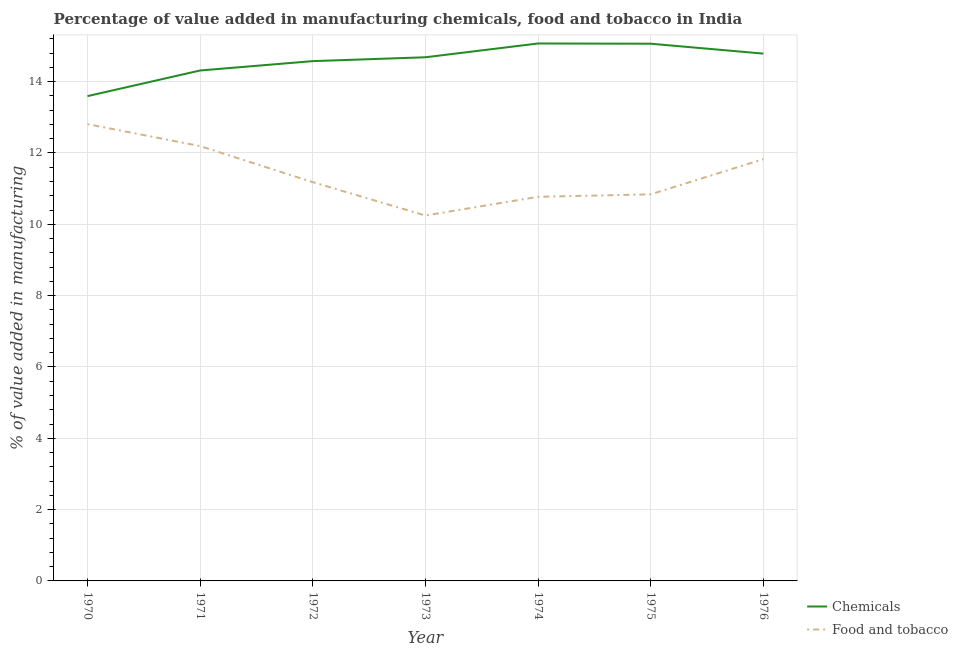Does the line corresponding to value added by  manufacturing chemicals intersect with the line corresponding to value added by manufacturing food and tobacco?
Ensure brevity in your answer.  No. Is the number of lines equal to the number of legend labels?
Provide a short and direct response. Yes. What is the value added by manufacturing food and tobacco in 1970?
Your response must be concise. 12.81. Across all years, what is the maximum value added by  manufacturing chemicals?
Give a very brief answer. 15.07. Across all years, what is the minimum value added by  manufacturing chemicals?
Make the answer very short. 13.59. In which year was the value added by manufacturing food and tobacco maximum?
Provide a short and direct response. 1970. What is the total value added by manufacturing food and tobacco in the graph?
Provide a short and direct response. 79.87. What is the difference between the value added by manufacturing food and tobacco in 1971 and that in 1974?
Give a very brief answer. 1.42. What is the difference between the value added by manufacturing food and tobacco in 1970 and the value added by  manufacturing chemicals in 1971?
Your response must be concise. -1.5. What is the average value added by manufacturing food and tobacco per year?
Give a very brief answer. 11.41. In the year 1976, what is the difference between the value added by manufacturing food and tobacco and value added by  manufacturing chemicals?
Offer a terse response. -2.96. In how many years, is the value added by manufacturing food and tobacco greater than 12.4 %?
Your response must be concise. 1. What is the ratio of the value added by  manufacturing chemicals in 1970 to that in 1974?
Offer a very short reply. 0.9. Is the value added by manufacturing food and tobacco in 1971 less than that in 1973?
Your answer should be compact. No. Is the difference between the value added by  manufacturing chemicals in 1971 and 1972 greater than the difference between the value added by manufacturing food and tobacco in 1971 and 1972?
Give a very brief answer. No. What is the difference between the highest and the second highest value added by  manufacturing chemicals?
Provide a succinct answer. 0.01. What is the difference between the highest and the lowest value added by  manufacturing chemicals?
Provide a short and direct response. 1.48. In how many years, is the value added by manufacturing food and tobacco greater than the average value added by manufacturing food and tobacco taken over all years?
Make the answer very short. 3. Is the sum of the value added by  manufacturing chemicals in 1971 and 1973 greater than the maximum value added by manufacturing food and tobacco across all years?
Make the answer very short. Yes. Is the value added by manufacturing food and tobacco strictly greater than the value added by  manufacturing chemicals over the years?
Give a very brief answer. No. How many lines are there?
Offer a very short reply. 2. How many years are there in the graph?
Offer a very short reply. 7. Are the values on the major ticks of Y-axis written in scientific E-notation?
Ensure brevity in your answer.  No. Does the graph contain any zero values?
Give a very brief answer. No. Does the graph contain grids?
Keep it short and to the point. Yes. How many legend labels are there?
Your answer should be very brief. 2. What is the title of the graph?
Offer a very short reply. Percentage of value added in manufacturing chemicals, food and tobacco in India. What is the label or title of the X-axis?
Offer a very short reply. Year. What is the label or title of the Y-axis?
Keep it short and to the point. % of value added in manufacturing. What is the % of value added in manufacturing of Chemicals in 1970?
Your answer should be compact. 13.59. What is the % of value added in manufacturing of Food and tobacco in 1970?
Ensure brevity in your answer.  12.81. What is the % of value added in manufacturing in Chemicals in 1971?
Provide a short and direct response. 14.31. What is the % of value added in manufacturing in Food and tobacco in 1971?
Make the answer very short. 12.19. What is the % of value added in manufacturing of Chemicals in 1972?
Ensure brevity in your answer.  14.58. What is the % of value added in manufacturing in Food and tobacco in 1972?
Make the answer very short. 11.18. What is the % of value added in manufacturing in Chemicals in 1973?
Your response must be concise. 14.68. What is the % of value added in manufacturing in Food and tobacco in 1973?
Your answer should be very brief. 10.25. What is the % of value added in manufacturing of Chemicals in 1974?
Your response must be concise. 15.07. What is the % of value added in manufacturing of Food and tobacco in 1974?
Your answer should be compact. 10.77. What is the % of value added in manufacturing in Chemicals in 1975?
Your response must be concise. 15.06. What is the % of value added in manufacturing of Food and tobacco in 1975?
Provide a short and direct response. 10.84. What is the % of value added in manufacturing in Chemicals in 1976?
Keep it short and to the point. 14.79. What is the % of value added in manufacturing of Food and tobacco in 1976?
Your answer should be very brief. 11.83. Across all years, what is the maximum % of value added in manufacturing in Chemicals?
Offer a terse response. 15.07. Across all years, what is the maximum % of value added in manufacturing of Food and tobacco?
Ensure brevity in your answer.  12.81. Across all years, what is the minimum % of value added in manufacturing of Chemicals?
Provide a succinct answer. 13.59. Across all years, what is the minimum % of value added in manufacturing in Food and tobacco?
Your response must be concise. 10.25. What is the total % of value added in manufacturing in Chemicals in the graph?
Offer a very short reply. 102.09. What is the total % of value added in manufacturing of Food and tobacco in the graph?
Make the answer very short. 79.87. What is the difference between the % of value added in manufacturing of Chemicals in 1970 and that in 1971?
Make the answer very short. -0.72. What is the difference between the % of value added in manufacturing in Food and tobacco in 1970 and that in 1971?
Make the answer very short. 0.62. What is the difference between the % of value added in manufacturing of Chemicals in 1970 and that in 1972?
Provide a short and direct response. -0.98. What is the difference between the % of value added in manufacturing of Food and tobacco in 1970 and that in 1972?
Your response must be concise. 1.63. What is the difference between the % of value added in manufacturing in Chemicals in 1970 and that in 1973?
Give a very brief answer. -1.09. What is the difference between the % of value added in manufacturing of Food and tobacco in 1970 and that in 1973?
Your response must be concise. 2.56. What is the difference between the % of value added in manufacturing of Chemicals in 1970 and that in 1974?
Your answer should be very brief. -1.48. What is the difference between the % of value added in manufacturing of Food and tobacco in 1970 and that in 1974?
Offer a very short reply. 2.04. What is the difference between the % of value added in manufacturing of Chemicals in 1970 and that in 1975?
Ensure brevity in your answer.  -1.47. What is the difference between the % of value added in manufacturing of Food and tobacco in 1970 and that in 1975?
Keep it short and to the point. 1.97. What is the difference between the % of value added in manufacturing of Chemicals in 1970 and that in 1976?
Offer a very short reply. -1.19. What is the difference between the % of value added in manufacturing of Food and tobacco in 1970 and that in 1976?
Provide a succinct answer. 0.98. What is the difference between the % of value added in manufacturing in Chemicals in 1971 and that in 1972?
Your response must be concise. -0.26. What is the difference between the % of value added in manufacturing in Food and tobacco in 1971 and that in 1972?
Provide a succinct answer. 1.01. What is the difference between the % of value added in manufacturing of Chemicals in 1971 and that in 1973?
Offer a very short reply. -0.37. What is the difference between the % of value added in manufacturing in Food and tobacco in 1971 and that in 1973?
Offer a terse response. 1.95. What is the difference between the % of value added in manufacturing of Chemicals in 1971 and that in 1974?
Provide a short and direct response. -0.76. What is the difference between the % of value added in manufacturing in Food and tobacco in 1971 and that in 1974?
Provide a short and direct response. 1.42. What is the difference between the % of value added in manufacturing of Chemicals in 1971 and that in 1975?
Your answer should be compact. -0.75. What is the difference between the % of value added in manufacturing in Food and tobacco in 1971 and that in 1975?
Your answer should be compact. 1.35. What is the difference between the % of value added in manufacturing in Chemicals in 1971 and that in 1976?
Your response must be concise. -0.47. What is the difference between the % of value added in manufacturing of Food and tobacco in 1971 and that in 1976?
Your answer should be very brief. 0.37. What is the difference between the % of value added in manufacturing of Chemicals in 1972 and that in 1973?
Your answer should be very brief. -0.11. What is the difference between the % of value added in manufacturing of Food and tobacco in 1972 and that in 1973?
Make the answer very short. 0.94. What is the difference between the % of value added in manufacturing in Chemicals in 1972 and that in 1974?
Offer a terse response. -0.49. What is the difference between the % of value added in manufacturing in Food and tobacco in 1972 and that in 1974?
Your answer should be compact. 0.41. What is the difference between the % of value added in manufacturing in Chemicals in 1972 and that in 1975?
Offer a terse response. -0.49. What is the difference between the % of value added in manufacturing of Food and tobacco in 1972 and that in 1975?
Provide a short and direct response. 0.34. What is the difference between the % of value added in manufacturing in Chemicals in 1972 and that in 1976?
Make the answer very short. -0.21. What is the difference between the % of value added in manufacturing in Food and tobacco in 1972 and that in 1976?
Offer a terse response. -0.65. What is the difference between the % of value added in manufacturing in Chemicals in 1973 and that in 1974?
Provide a succinct answer. -0.39. What is the difference between the % of value added in manufacturing in Food and tobacco in 1973 and that in 1974?
Offer a very short reply. -0.52. What is the difference between the % of value added in manufacturing in Chemicals in 1973 and that in 1975?
Make the answer very short. -0.38. What is the difference between the % of value added in manufacturing of Food and tobacco in 1973 and that in 1975?
Your response must be concise. -0.59. What is the difference between the % of value added in manufacturing of Chemicals in 1973 and that in 1976?
Provide a succinct answer. -0.1. What is the difference between the % of value added in manufacturing in Food and tobacco in 1973 and that in 1976?
Keep it short and to the point. -1.58. What is the difference between the % of value added in manufacturing of Chemicals in 1974 and that in 1975?
Make the answer very short. 0.01. What is the difference between the % of value added in manufacturing in Food and tobacco in 1974 and that in 1975?
Your answer should be very brief. -0.07. What is the difference between the % of value added in manufacturing of Chemicals in 1974 and that in 1976?
Offer a very short reply. 0.28. What is the difference between the % of value added in manufacturing of Food and tobacco in 1974 and that in 1976?
Your response must be concise. -1.06. What is the difference between the % of value added in manufacturing of Chemicals in 1975 and that in 1976?
Provide a short and direct response. 0.28. What is the difference between the % of value added in manufacturing in Food and tobacco in 1975 and that in 1976?
Provide a succinct answer. -0.99. What is the difference between the % of value added in manufacturing in Chemicals in 1970 and the % of value added in manufacturing in Food and tobacco in 1971?
Your answer should be compact. 1.4. What is the difference between the % of value added in manufacturing in Chemicals in 1970 and the % of value added in manufacturing in Food and tobacco in 1972?
Offer a terse response. 2.41. What is the difference between the % of value added in manufacturing in Chemicals in 1970 and the % of value added in manufacturing in Food and tobacco in 1973?
Offer a terse response. 3.35. What is the difference between the % of value added in manufacturing of Chemicals in 1970 and the % of value added in manufacturing of Food and tobacco in 1974?
Provide a succinct answer. 2.82. What is the difference between the % of value added in manufacturing in Chemicals in 1970 and the % of value added in manufacturing in Food and tobacco in 1975?
Offer a terse response. 2.75. What is the difference between the % of value added in manufacturing in Chemicals in 1970 and the % of value added in manufacturing in Food and tobacco in 1976?
Your response must be concise. 1.77. What is the difference between the % of value added in manufacturing in Chemicals in 1971 and the % of value added in manufacturing in Food and tobacco in 1972?
Ensure brevity in your answer.  3.13. What is the difference between the % of value added in manufacturing in Chemicals in 1971 and the % of value added in manufacturing in Food and tobacco in 1973?
Offer a terse response. 4.07. What is the difference between the % of value added in manufacturing in Chemicals in 1971 and the % of value added in manufacturing in Food and tobacco in 1974?
Offer a very short reply. 3.54. What is the difference between the % of value added in manufacturing in Chemicals in 1971 and the % of value added in manufacturing in Food and tobacco in 1975?
Your answer should be very brief. 3.47. What is the difference between the % of value added in manufacturing in Chemicals in 1971 and the % of value added in manufacturing in Food and tobacco in 1976?
Provide a succinct answer. 2.49. What is the difference between the % of value added in manufacturing in Chemicals in 1972 and the % of value added in manufacturing in Food and tobacco in 1973?
Provide a short and direct response. 4.33. What is the difference between the % of value added in manufacturing of Chemicals in 1972 and the % of value added in manufacturing of Food and tobacco in 1974?
Your answer should be very brief. 3.8. What is the difference between the % of value added in manufacturing in Chemicals in 1972 and the % of value added in manufacturing in Food and tobacco in 1975?
Offer a terse response. 3.74. What is the difference between the % of value added in manufacturing in Chemicals in 1972 and the % of value added in manufacturing in Food and tobacco in 1976?
Offer a very short reply. 2.75. What is the difference between the % of value added in manufacturing in Chemicals in 1973 and the % of value added in manufacturing in Food and tobacco in 1974?
Provide a succinct answer. 3.91. What is the difference between the % of value added in manufacturing in Chemicals in 1973 and the % of value added in manufacturing in Food and tobacco in 1975?
Your response must be concise. 3.84. What is the difference between the % of value added in manufacturing of Chemicals in 1973 and the % of value added in manufacturing of Food and tobacco in 1976?
Provide a short and direct response. 2.86. What is the difference between the % of value added in manufacturing of Chemicals in 1974 and the % of value added in manufacturing of Food and tobacco in 1975?
Your response must be concise. 4.23. What is the difference between the % of value added in manufacturing of Chemicals in 1974 and the % of value added in manufacturing of Food and tobacco in 1976?
Ensure brevity in your answer.  3.24. What is the difference between the % of value added in manufacturing in Chemicals in 1975 and the % of value added in manufacturing in Food and tobacco in 1976?
Give a very brief answer. 3.24. What is the average % of value added in manufacturing of Chemicals per year?
Make the answer very short. 14.58. What is the average % of value added in manufacturing of Food and tobacco per year?
Provide a succinct answer. 11.41. In the year 1970, what is the difference between the % of value added in manufacturing in Chemicals and % of value added in manufacturing in Food and tobacco?
Offer a terse response. 0.79. In the year 1971, what is the difference between the % of value added in manufacturing in Chemicals and % of value added in manufacturing in Food and tobacco?
Make the answer very short. 2.12. In the year 1972, what is the difference between the % of value added in manufacturing in Chemicals and % of value added in manufacturing in Food and tobacco?
Offer a very short reply. 3.39. In the year 1973, what is the difference between the % of value added in manufacturing in Chemicals and % of value added in manufacturing in Food and tobacco?
Your response must be concise. 4.44. In the year 1974, what is the difference between the % of value added in manufacturing in Chemicals and % of value added in manufacturing in Food and tobacco?
Provide a short and direct response. 4.3. In the year 1975, what is the difference between the % of value added in manufacturing in Chemicals and % of value added in manufacturing in Food and tobacco?
Provide a short and direct response. 4.22. In the year 1976, what is the difference between the % of value added in manufacturing in Chemicals and % of value added in manufacturing in Food and tobacco?
Your answer should be compact. 2.96. What is the ratio of the % of value added in manufacturing of Chemicals in 1970 to that in 1971?
Offer a terse response. 0.95. What is the ratio of the % of value added in manufacturing in Food and tobacco in 1970 to that in 1971?
Offer a very short reply. 1.05. What is the ratio of the % of value added in manufacturing in Chemicals in 1970 to that in 1972?
Offer a very short reply. 0.93. What is the ratio of the % of value added in manufacturing in Food and tobacco in 1970 to that in 1972?
Your answer should be very brief. 1.15. What is the ratio of the % of value added in manufacturing in Chemicals in 1970 to that in 1973?
Make the answer very short. 0.93. What is the ratio of the % of value added in manufacturing of Food and tobacco in 1970 to that in 1973?
Your answer should be compact. 1.25. What is the ratio of the % of value added in manufacturing in Chemicals in 1970 to that in 1974?
Give a very brief answer. 0.9. What is the ratio of the % of value added in manufacturing in Food and tobacco in 1970 to that in 1974?
Offer a very short reply. 1.19. What is the ratio of the % of value added in manufacturing of Chemicals in 1970 to that in 1975?
Keep it short and to the point. 0.9. What is the ratio of the % of value added in manufacturing of Food and tobacco in 1970 to that in 1975?
Your answer should be compact. 1.18. What is the ratio of the % of value added in manufacturing in Chemicals in 1970 to that in 1976?
Give a very brief answer. 0.92. What is the ratio of the % of value added in manufacturing of Food and tobacco in 1970 to that in 1976?
Ensure brevity in your answer.  1.08. What is the ratio of the % of value added in manufacturing in Food and tobacco in 1971 to that in 1972?
Give a very brief answer. 1.09. What is the ratio of the % of value added in manufacturing of Chemicals in 1971 to that in 1973?
Provide a short and direct response. 0.97. What is the ratio of the % of value added in manufacturing of Food and tobacco in 1971 to that in 1973?
Make the answer very short. 1.19. What is the ratio of the % of value added in manufacturing in Chemicals in 1971 to that in 1974?
Your answer should be very brief. 0.95. What is the ratio of the % of value added in manufacturing of Food and tobacco in 1971 to that in 1974?
Make the answer very short. 1.13. What is the ratio of the % of value added in manufacturing in Chemicals in 1971 to that in 1975?
Your answer should be very brief. 0.95. What is the ratio of the % of value added in manufacturing in Food and tobacco in 1971 to that in 1975?
Ensure brevity in your answer.  1.12. What is the ratio of the % of value added in manufacturing of Chemicals in 1971 to that in 1976?
Make the answer very short. 0.97. What is the ratio of the % of value added in manufacturing of Food and tobacco in 1971 to that in 1976?
Keep it short and to the point. 1.03. What is the ratio of the % of value added in manufacturing of Chemicals in 1972 to that in 1973?
Make the answer very short. 0.99. What is the ratio of the % of value added in manufacturing in Food and tobacco in 1972 to that in 1973?
Your answer should be very brief. 1.09. What is the ratio of the % of value added in manufacturing of Chemicals in 1972 to that in 1974?
Make the answer very short. 0.97. What is the ratio of the % of value added in manufacturing of Food and tobacco in 1972 to that in 1974?
Your answer should be very brief. 1.04. What is the ratio of the % of value added in manufacturing of Chemicals in 1972 to that in 1975?
Keep it short and to the point. 0.97. What is the ratio of the % of value added in manufacturing in Food and tobacco in 1972 to that in 1975?
Ensure brevity in your answer.  1.03. What is the ratio of the % of value added in manufacturing in Chemicals in 1972 to that in 1976?
Your answer should be compact. 0.99. What is the ratio of the % of value added in manufacturing in Food and tobacco in 1972 to that in 1976?
Offer a very short reply. 0.95. What is the ratio of the % of value added in manufacturing in Chemicals in 1973 to that in 1974?
Offer a terse response. 0.97. What is the ratio of the % of value added in manufacturing of Food and tobacco in 1973 to that in 1974?
Your answer should be very brief. 0.95. What is the ratio of the % of value added in manufacturing of Chemicals in 1973 to that in 1975?
Make the answer very short. 0.97. What is the ratio of the % of value added in manufacturing in Food and tobacco in 1973 to that in 1975?
Your response must be concise. 0.95. What is the ratio of the % of value added in manufacturing of Chemicals in 1973 to that in 1976?
Keep it short and to the point. 0.99. What is the ratio of the % of value added in manufacturing of Food and tobacco in 1973 to that in 1976?
Your response must be concise. 0.87. What is the ratio of the % of value added in manufacturing of Chemicals in 1974 to that in 1976?
Your answer should be compact. 1.02. What is the ratio of the % of value added in manufacturing of Food and tobacco in 1974 to that in 1976?
Provide a short and direct response. 0.91. What is the ratio of the % of value added in manufacturing of Chemicals in 1975 to that in 1976?
Your response must be concise. 1.02. What is the ratio of the % of value added in manufacturing of Food and tobacco in 1975 to that in 1976?
Provide a short and direct response. 0.92. What is the difference between the highest and the second highest % of value added in manufacturing in Chemicals?
Ensure brevity in your answer.  0.01. What is the difference between the highest and the second highest % of value added in manufacturing of Food and tobacco?
Make the answer very short. 0.62. What is the difference between the highest and the lowest % of value added in manufacturing in Chemicals?
Your answer should be compact. 1.48. What is the difference between the highest and the lowest % of value added in manufacturing of Food and tobacco?
Provide a succinct answer. 2.56. 